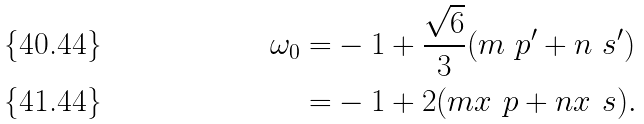<formula> <loc_0><loc_0><loc_500><loc_500>\omega _ { 0 } = & - 1 + \frac { \sqrt { 6 } } { 3 } ( m \ p ^ { \prime } + n \ s ^ { \prime } ) \\ = & - 1 + 2 ( m x _ { \ } p + n x _ { \ } s ) .</formula> 